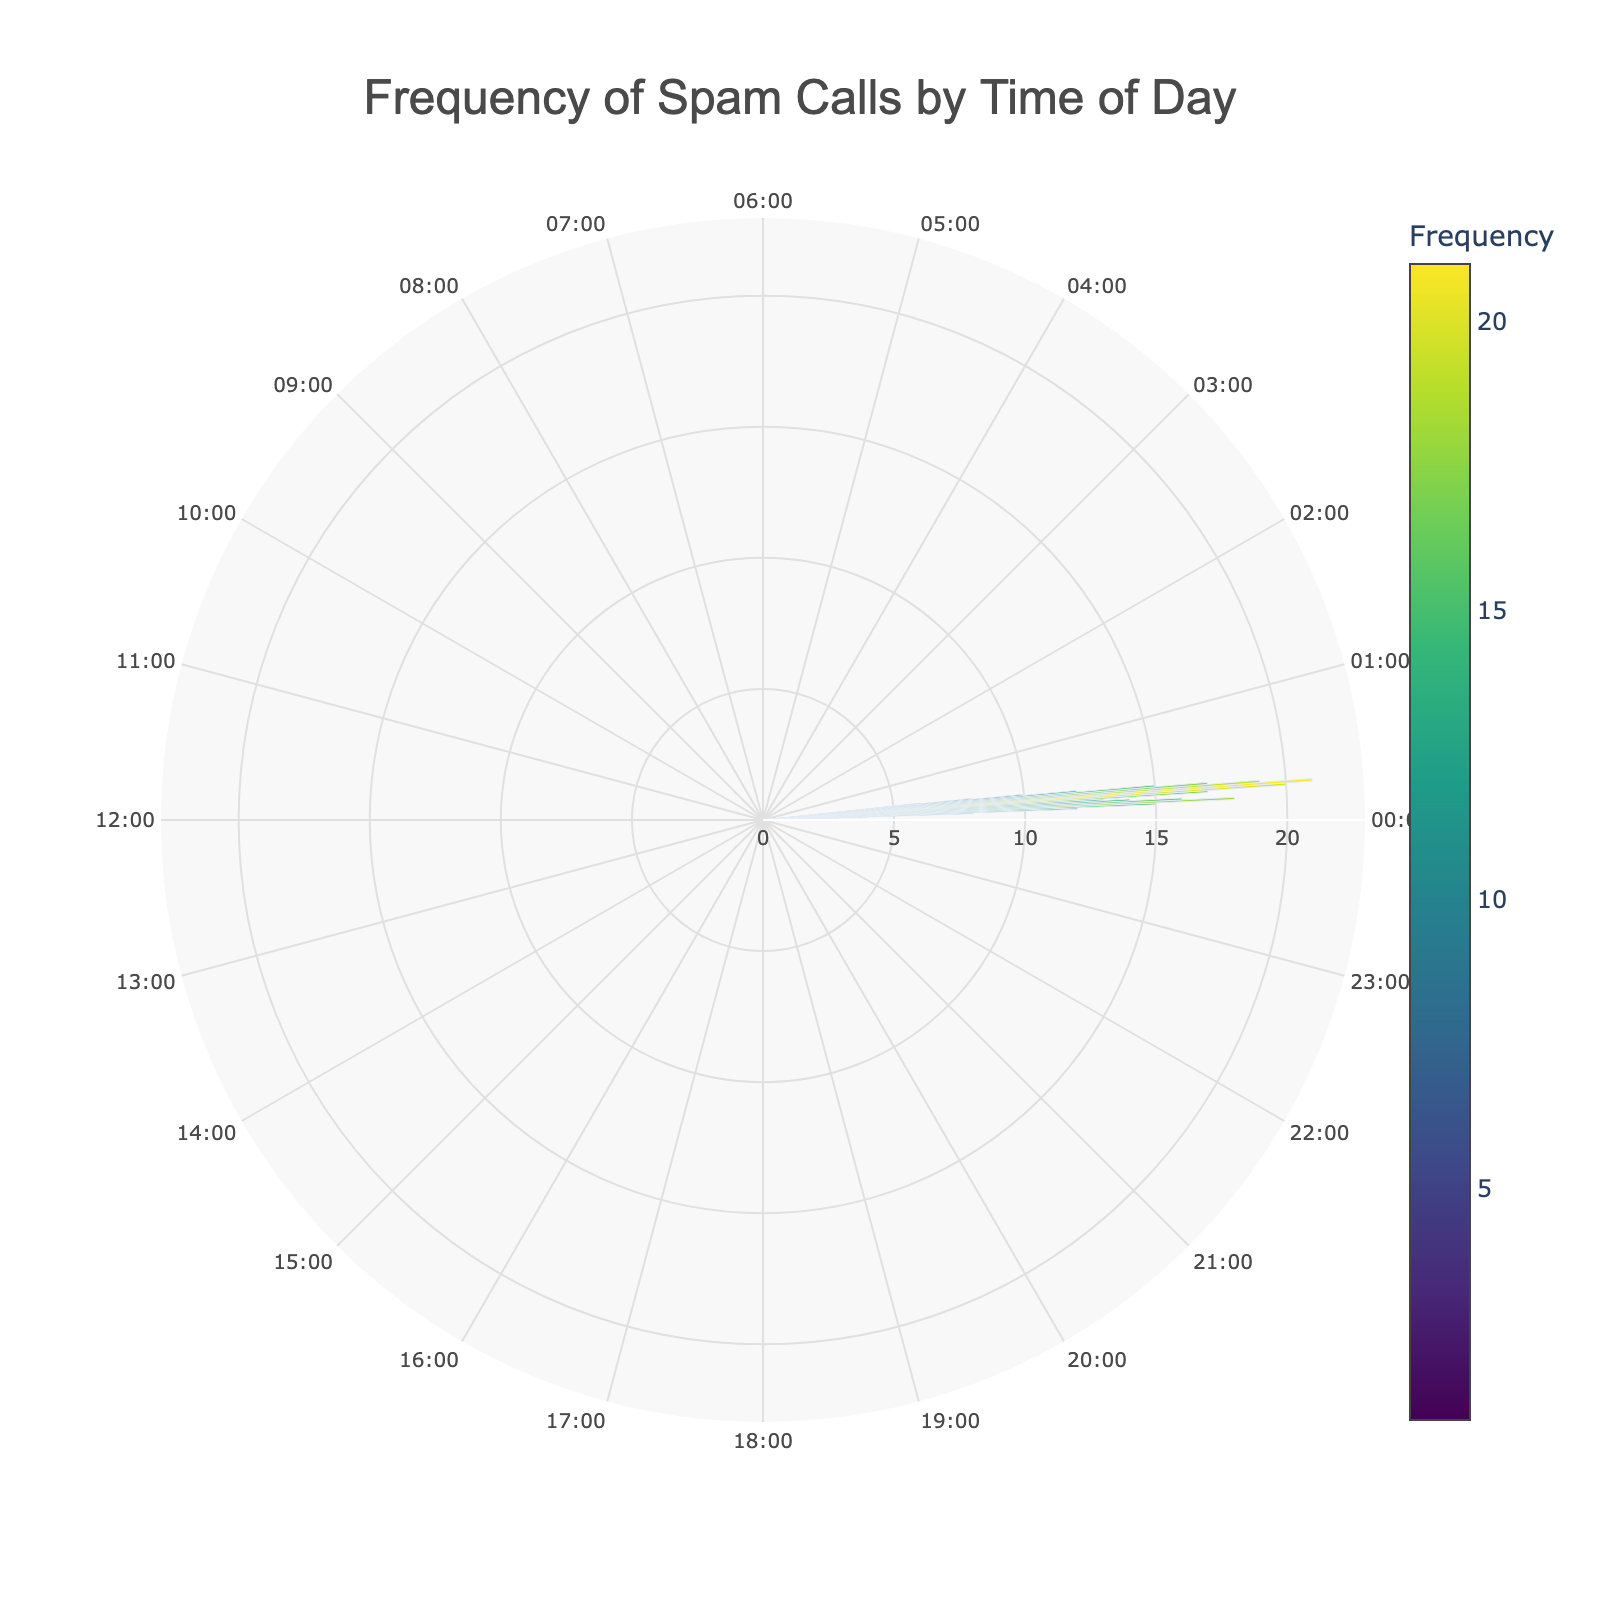What's the title of the chart? The title of the chart is located at the top center of the figure indicated with a larger font size. By looking at this text, you can easily identify the title.
Answer: Frequency of Spam Calls by Time of Day What's the frequency of spam calls between 09:00 and 10:00? To determine the frequency of spam calls between 09:00 and 10:00, locate the section of the chart where the time range is between 09:00 and 10:00 and find the corresponding frequency value indicated.
Answer: 15 During which time period is the lowest frequency of spam calls? To find the lowest frequency, examine the chart for the smallest value indicated in any of the segments. The specific time range can be identified from the hovertext or the position on the chart. The smallest frequency is 1.
Answer: 03:00-04:00 and 04:00-05:00 What is the combined frequency of spam calls from 16:00 to 18:00? To calculate the combined frequency, find the frequencies for 16:00-17:00 and 17:00-18:00 in the chart, then sum them up. The frequencies are 21 and 19, respectively.
Answer: 40 How does the frequency of spam calls at 14:00-15:00 compare to 22:00-23:00? Locate the frequency for the time ranges 14:00-15:00 and 22:00-23:00 on the chart. From the hovertext or segment size, you can identify the frequencies as 17 and 8, respectively. Compare these values directly.
Answer: 14:00-15:00 has more spam calls than 22:00-23:00 What time has the highest frequency of spam calls? To identify the time with the highest frequency, look for the segment with the largest frequency value on the chart. The highest frequency value is 21.
Answer: 16:00-17:00 What is the average frequency of spam calls between 08:00 and 12:00? Calculate the average by summing the frequencies of the time periods from 08:00-09:00 to 11:00-12:00, and then divide by the number of periods. The frequencies are 12, 15, 18, and 16 (total = 61). Divide by 4.
Answer: 15.25 What's the difference in spam call frequency between 10:00-11:00 and 14:00-15:00? Identify the frequencies for 10:00-11:00 and 14:00-15:00 from the chart, which are 18 and 17, respectively. Subtract the smaller frequency from the larger frequency to find the difference.
Answer: 1 Which period has more spam calls, 07:00-08:00 or 21:00-22:00? Locate the frequencies for 07:00-08:00 and 21:00-22:00 from the chart, which are 8 and 10, respectively. Compare these two values to determine the period with more spam calls.
Answer: 21:00-22:00 